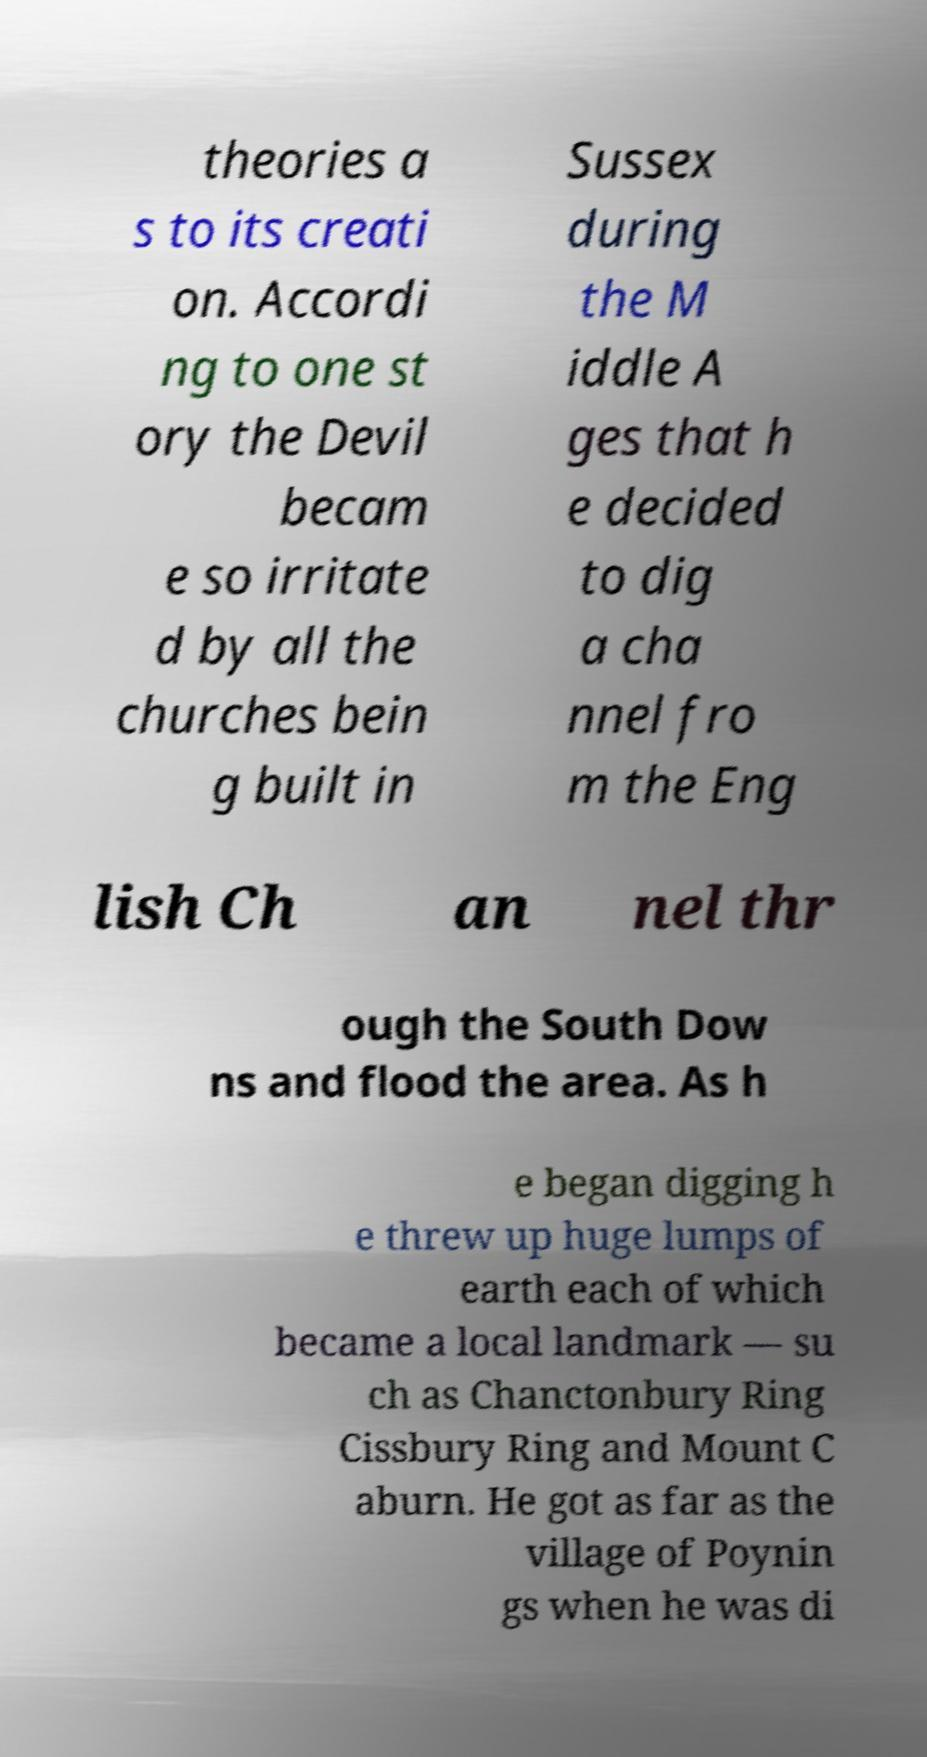What messages or text are displayed in this image? I need them in a readable, typed format. theories a s to its creati on. Accordi ng to one st ory the Devil becam e so irritate d by all the churches bein g built in Sussex during the M iddle A ges that h e decided to dig a cha nnel fro m the Eng lish Ch an nel thr ough the South Dow ns and flood the area. As h e began digging h e threw up huge lumps of earth each of which became a local landmark — su ch as Chanctonbury Ring Cissbury Ring and Mount C aburn. He got as far as the village of Poynin gs when he was di 